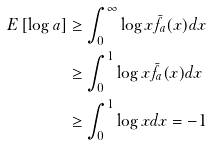<formula> <loc_0><loc_0><loc_500><loc_500>E \left [ \log a \right ] & \geq \int _ { 0 } ^ { \infty } \log x \bar { f } _ { a } ( x ) d x \\ & \geq \int _ { 0 } ^ { 1 } \log x \bar { f } _ { a } ( x ) d x \\ & \geq \int _ { 0 } ^ { 1 } \log x d x = - 1</formula> 